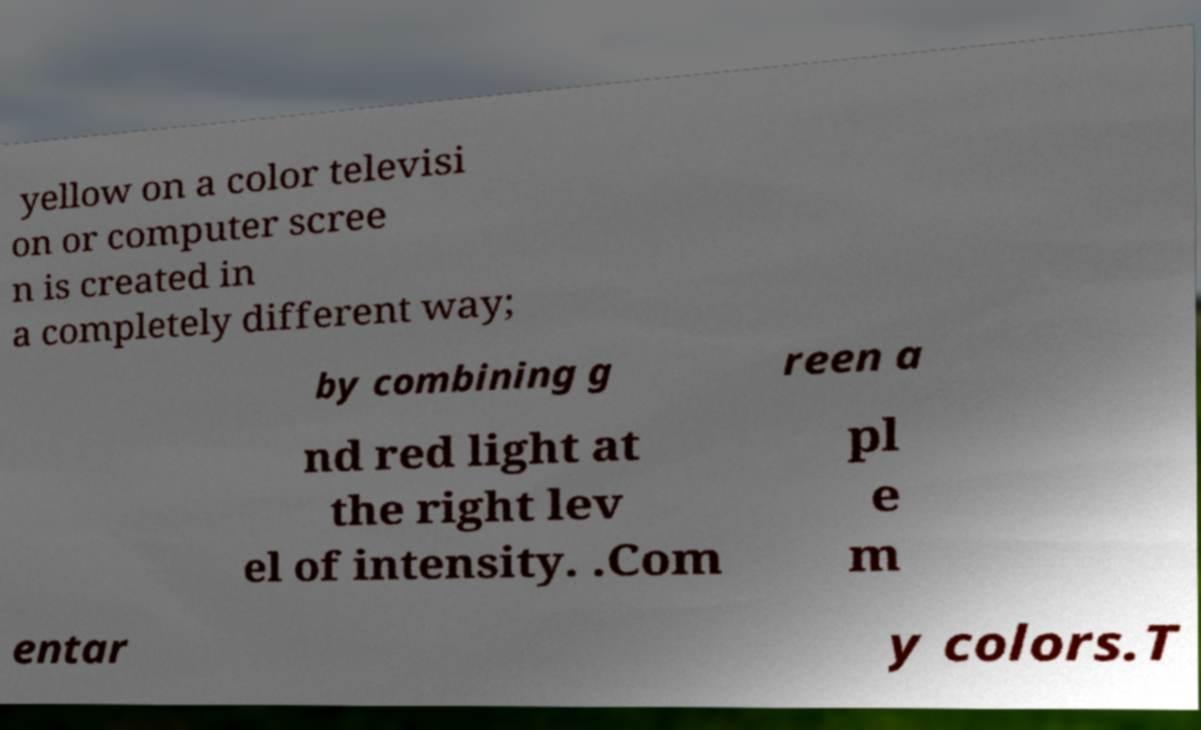Please identify and transcribe the text found in this image. yellow on a color televisi on or computer scree n is created in a completely different way; by combining g reen a nd red light at the right lev el of intensity. .Com pl e m entar y colors.T 